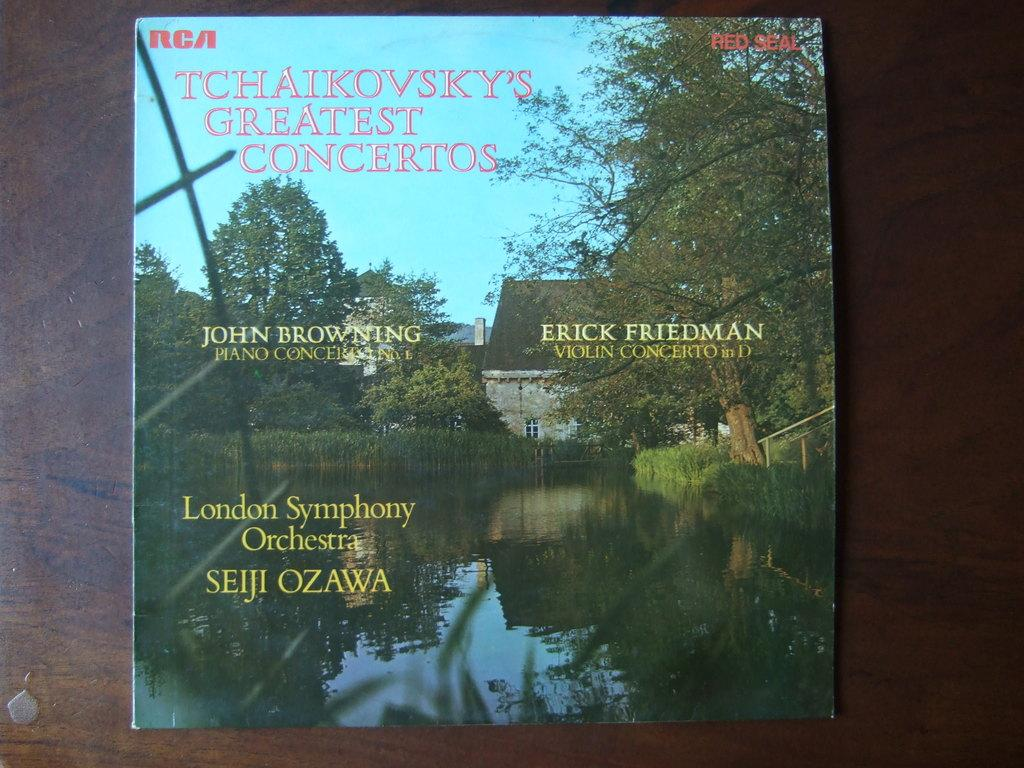<image>
Render a clear and concise summary of the photo. On a table is a copy of RCA RED SEAL Tchaikovsky's Greatest Concertos. 